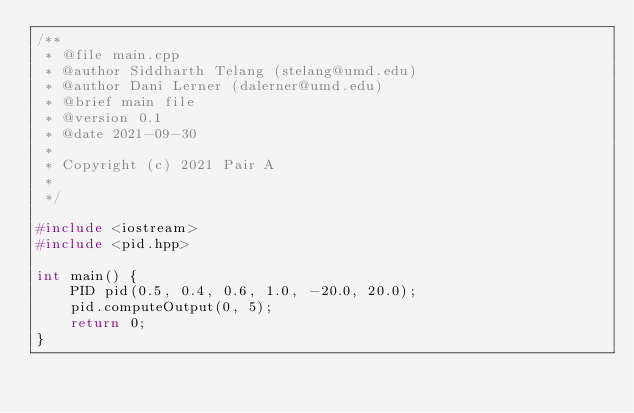Convert code to text. <code><loc_0><loc_0><loc_500><loc_500><_C++_>/**
 * @file main.cpp
 * @author Siddharth Telang (stelang@umd.edu)
 * @author Dani Lerner (dalerner@umd.edu)
 * @brief main file
 * @version 0.1
 * @date 2021-09-30
 * 
 * Copyright (c) 2021 Pair A
 * 
 */

#include <iostream>
#include <pid.hpp>

int main() {
    PID pid(0.5, 0.4, 0.6, 1.0, -20.0, 20.0);
    pid.computeOutput(0, 5);
    return 0;
}

</code> 